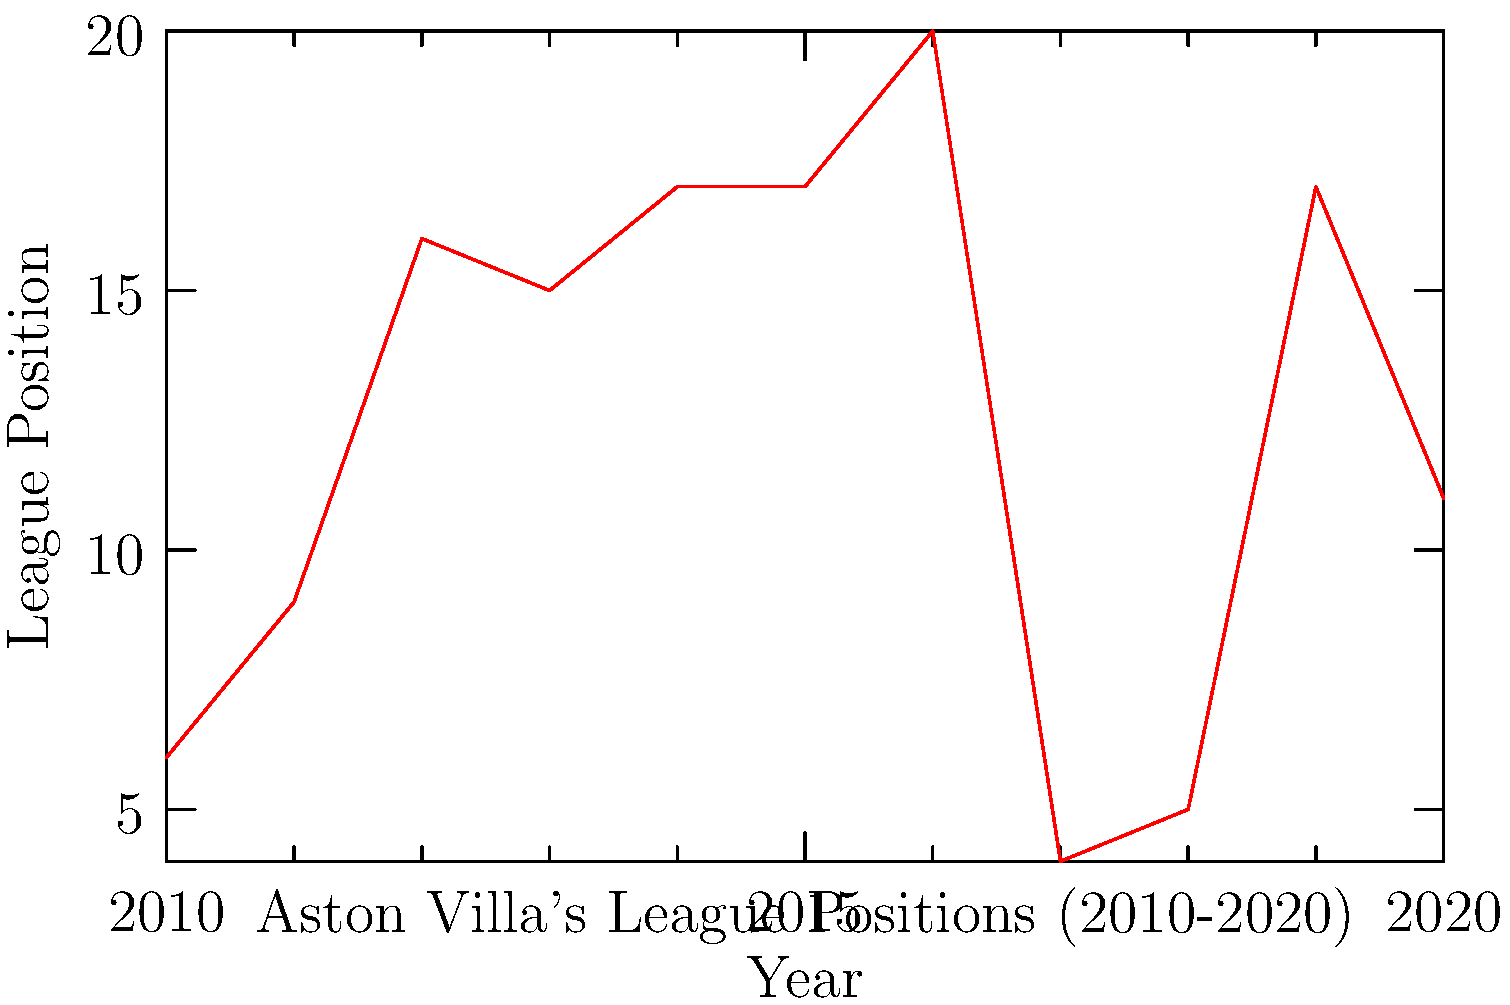Based on the line graph showing Aston Villa's historical league standings from 2010 to 2020, in which year did the team achieve its highest league position, and what factors might have contributed to this success? To answer this question, we need to analyze the graph step-by-step:

1. Examine the y-axis: It represents the league position, with lower numbers indicating higher positions (1st is the top of the league).

2. Scan the line graph for the lowest point: The lowest point on the graph represents the highest league position.

3. Identify the year: The lowest point occurs in 2010, corresponding to a 6th place finish.

4. Consider contributing factors:
   a) Strong squad: Aston Villa likely had a talented group of players in 2010.
   b) Effective management: The team's tactics and strategies were probably well-executed.
   c) Consistency: Maintaining a high position throughout the season requires consistent performance.
   d) Lack of injuries: The team may have avoided major injuries to key players.
   e) Favorable fixtures: The schedule might have been advantageous for Aston Villa that year.

5. Note the contrast: The graph shows a general decline in performance after 2010, with relegation (20th position) in 2016, followed by a resurgence in 2017-2018.

The highest league position achieved by Aston Villa in this period was 6th place in 2010. This success could be attributed to a combination of strong squad depth, effective management, consistent performance, minimal injuries, and possibly favorable fixtures.
Answer: 6th place in 2010 